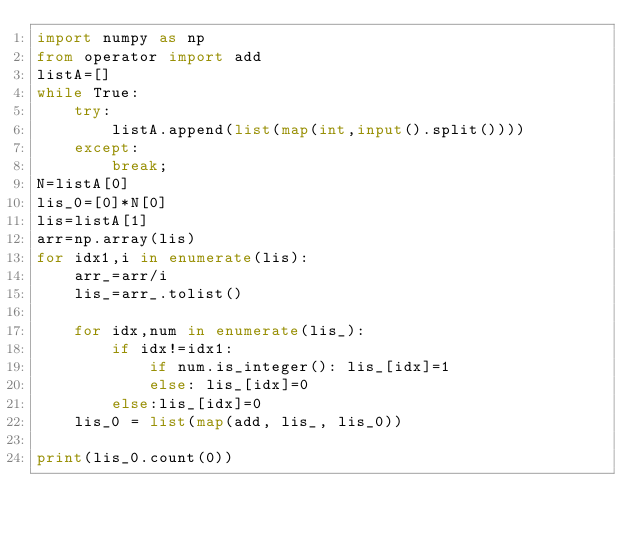Convert code to text. <code><loc_0><loc_0><loc_500><loc_500><_Python_>import numpy as np
from operator import add
listA=[]
while True:
    try:
        listA.append(list(map(int,input().split())))
    except:
        break;
N=listA[0]
lis_0=[0]*N[0]
lis=listA[1]
arr=np.array(lis)
for idx1,i in enumerate(lis):
    arr_=arr/i
    lis_=arr_.tolist()
    
    for idx,num in enumerate(lis_):
        if idx!=idx1:
            if num.is_integer(): lis_[idx]=1
            else: lis_[idx]=0
        else:lis_[idx]=0
    lis_0 = list(map(add, lis_, lis_0))
        
print(lis_0.count(0))</code> 